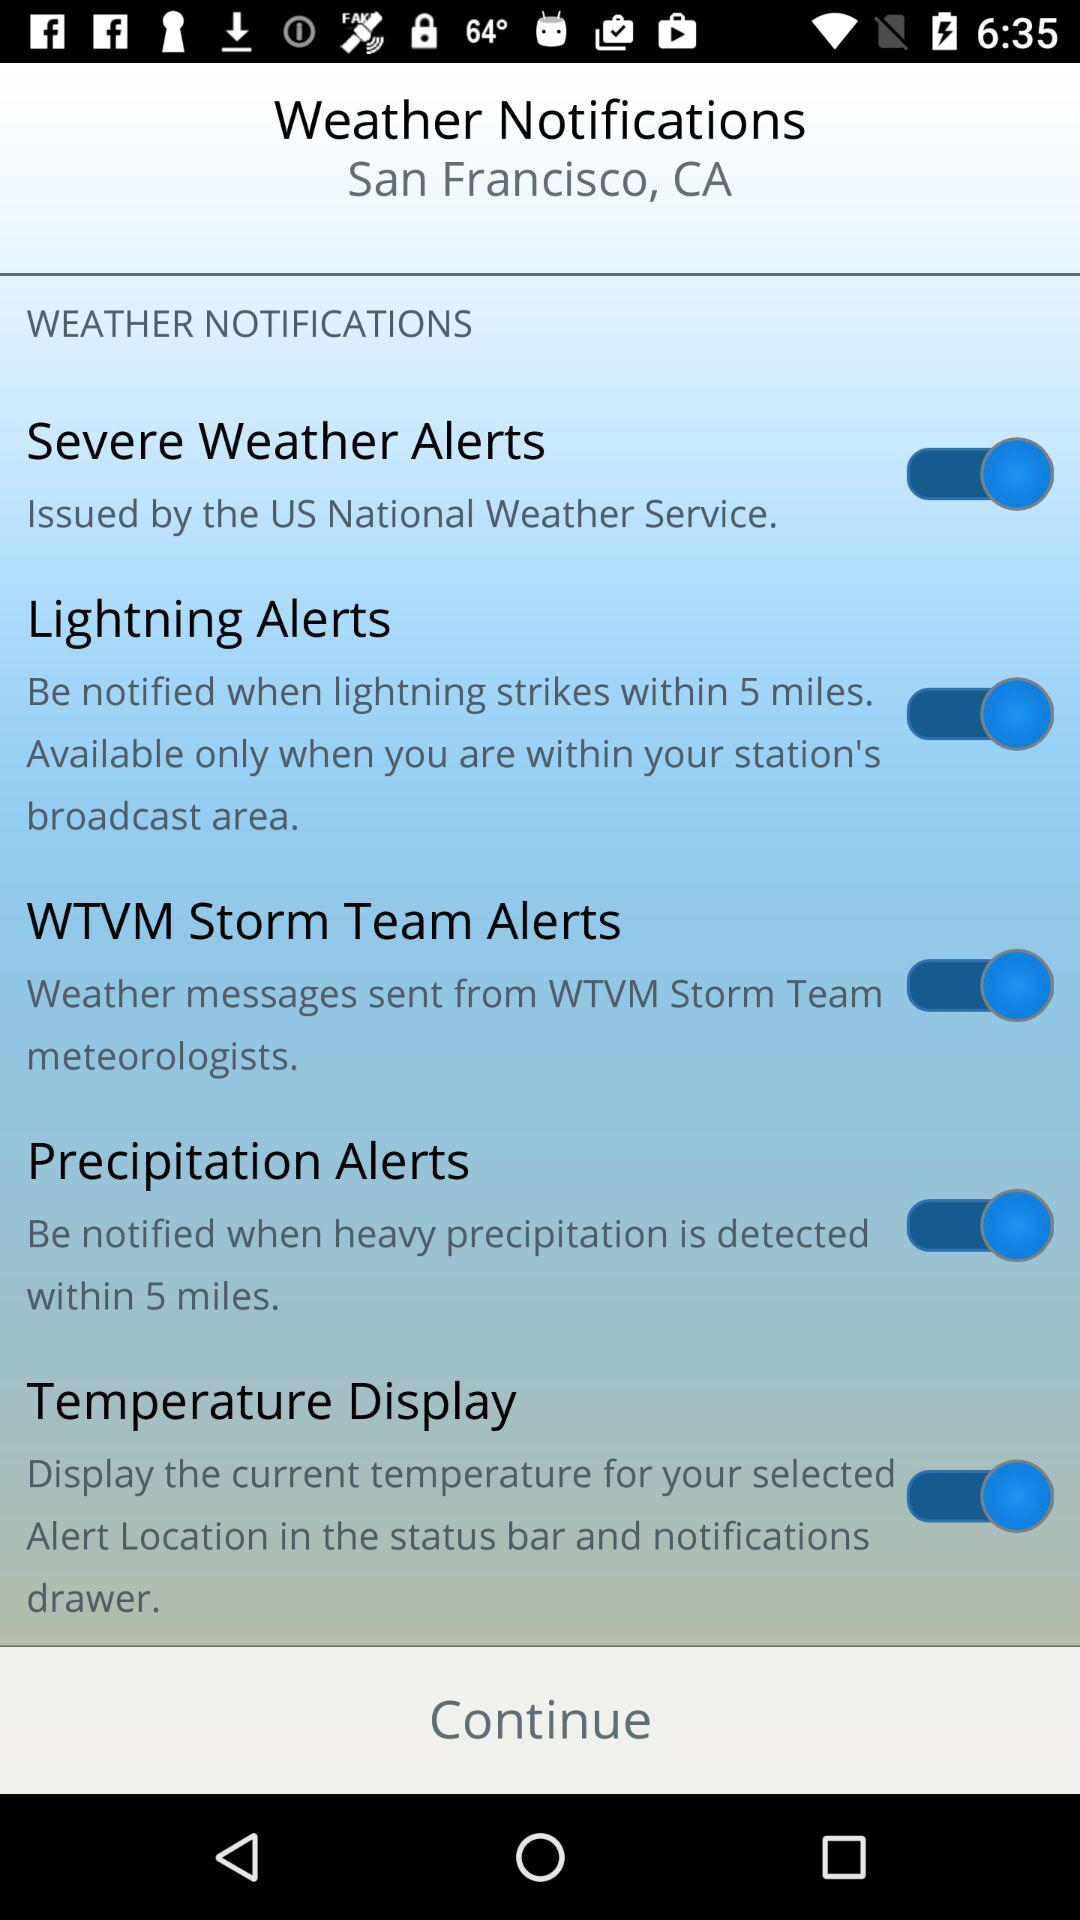What is the mentioned location? The mentioned location is San Francisco, California. 